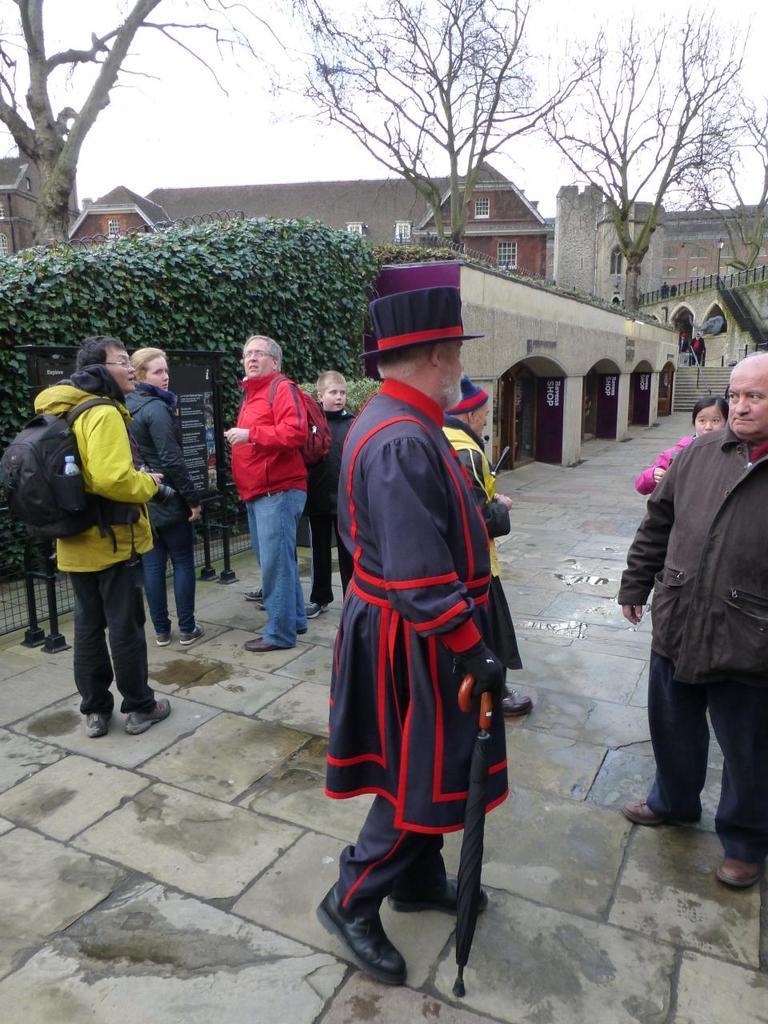Please provide a concise description of this image. This image is clicked outside. There are trees and bushes in the middle. There are buildings in the middle. There are some persons standing in the middle. There is sky at the top. 